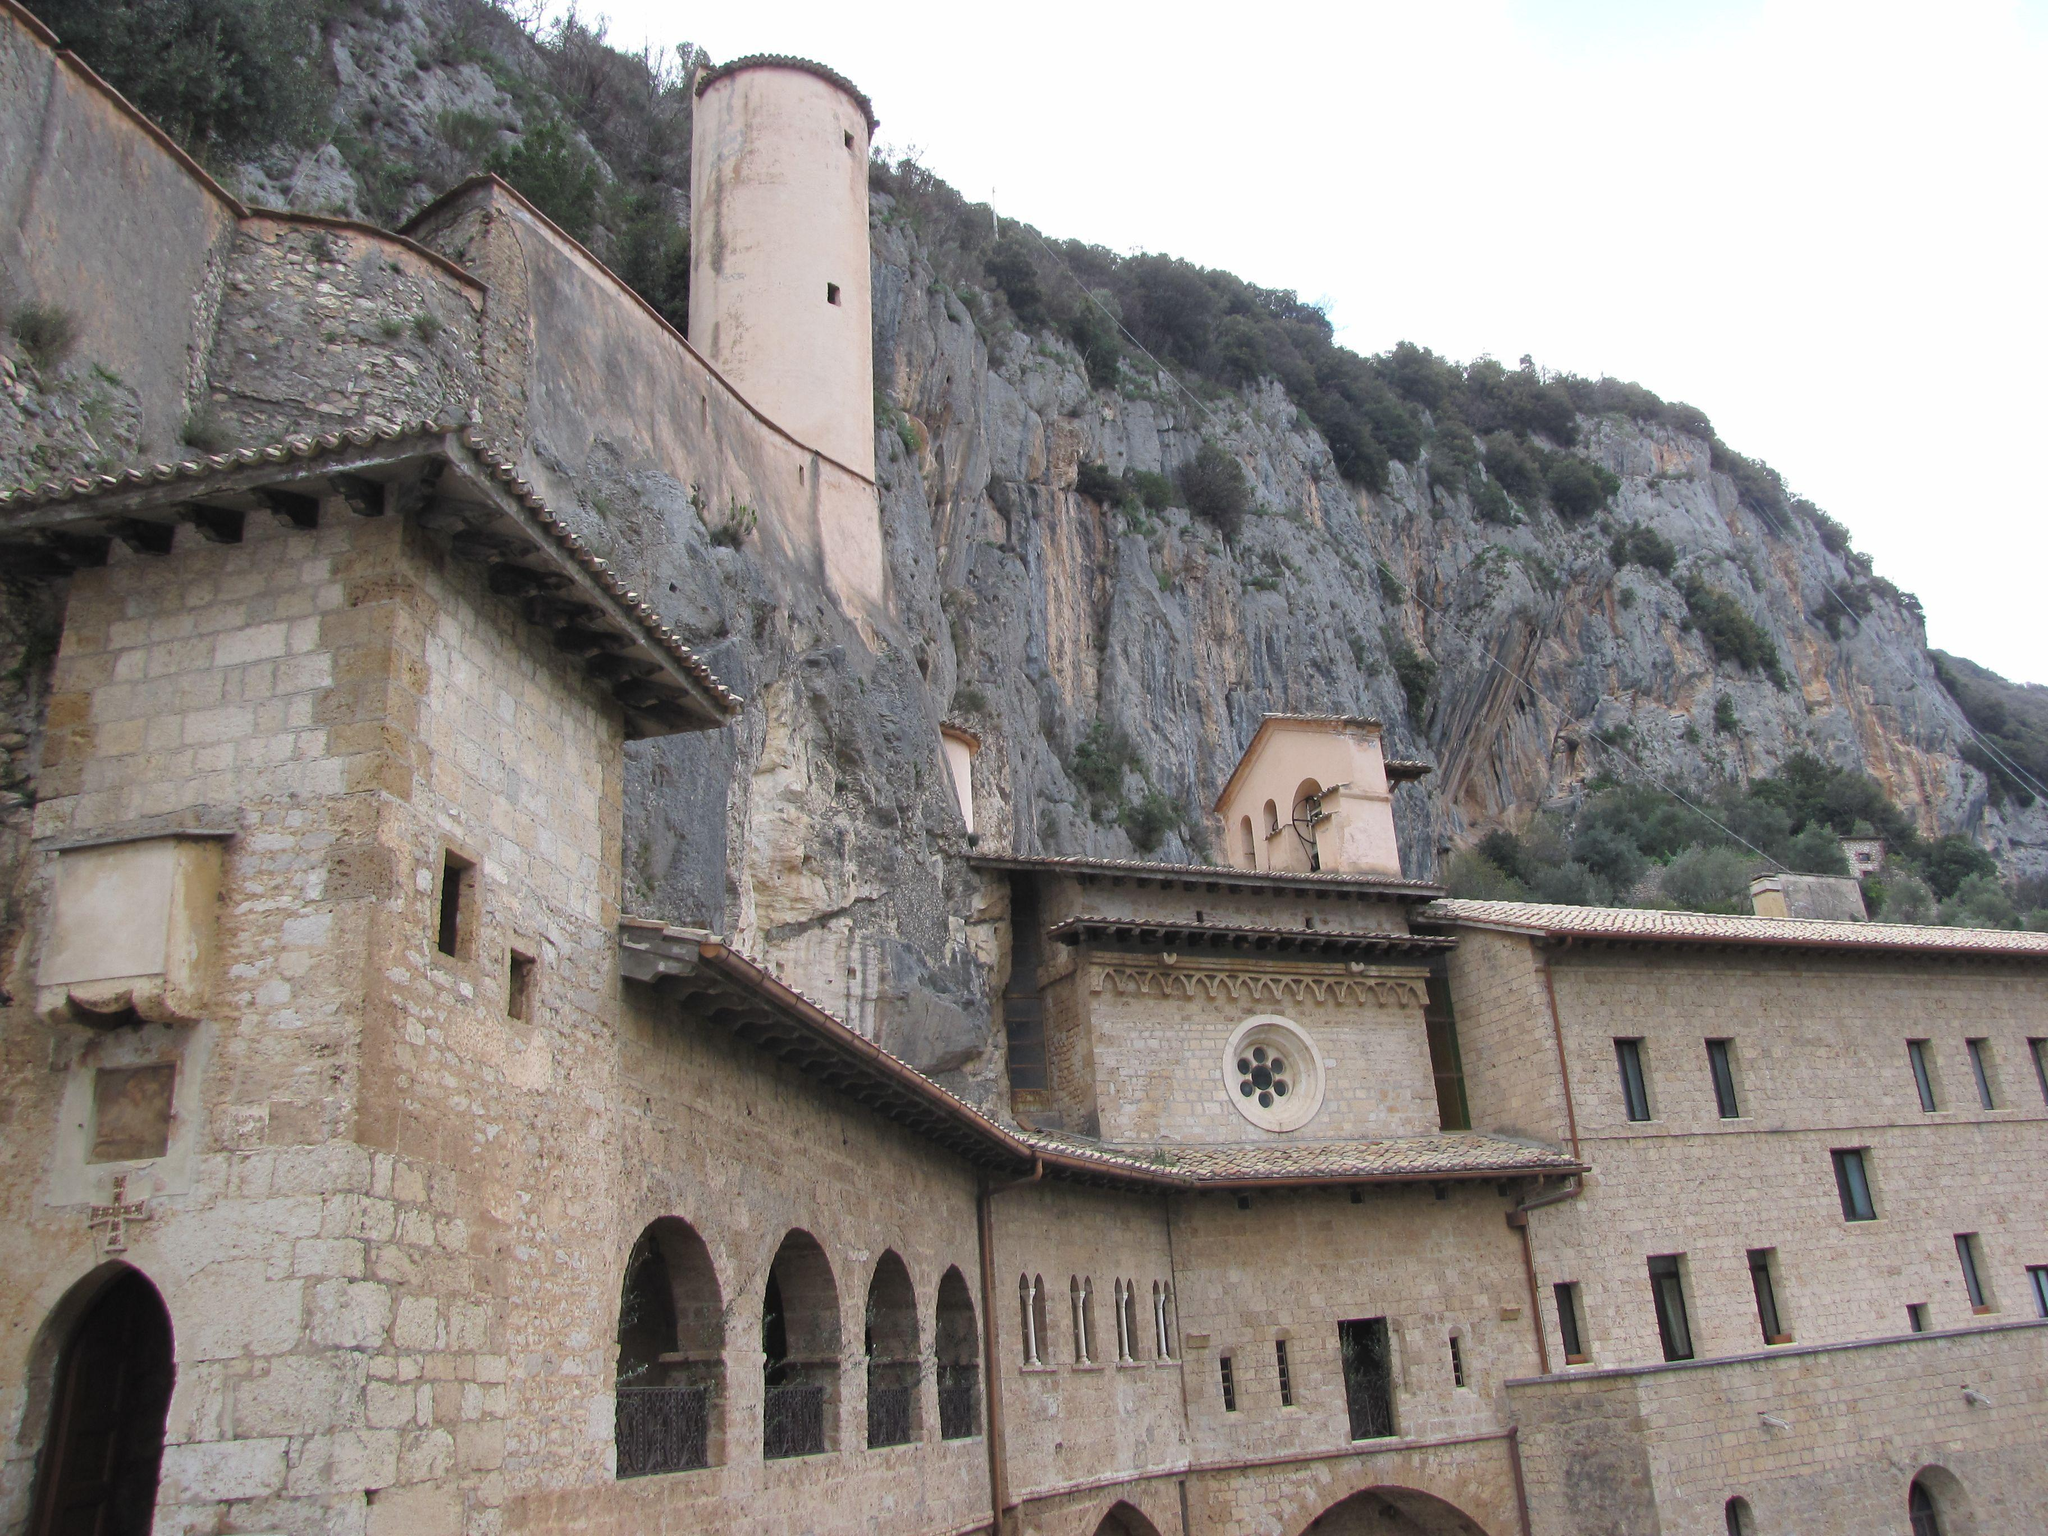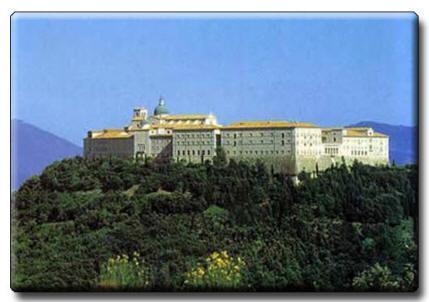The first image is the image on the left, the second image is the image on the right. For the images shown, is this caption "In at least one image there is a building built out of white brick carved in to the side of a mountain." true? Answer yes or no. Yes. 